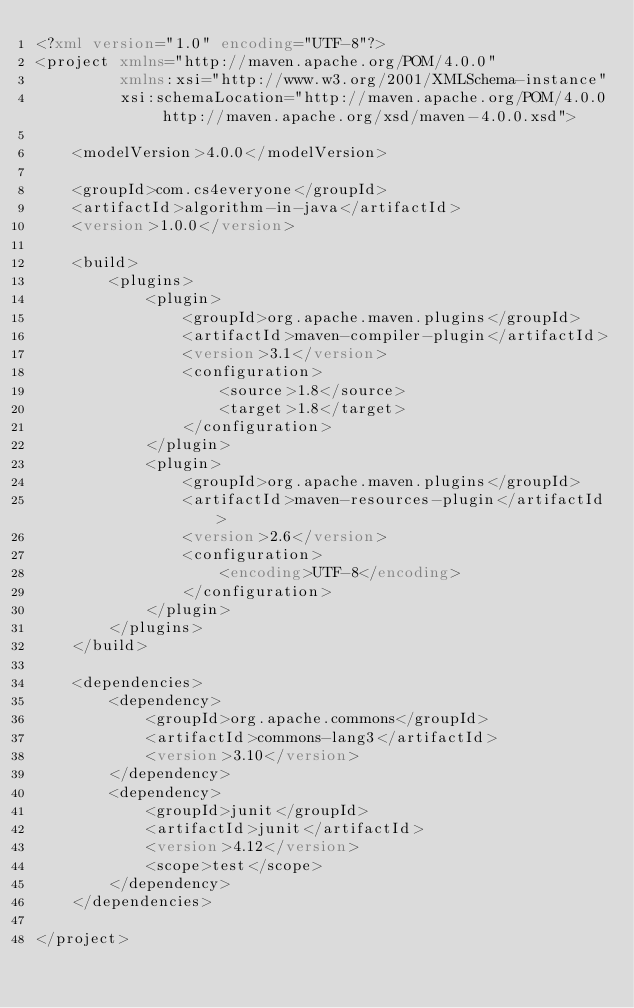Convert code to text. <code><loc_0><loc_0><loc_500><loc_500><_XML_><?xml version="1.0" encoding="UTF-8"?>
<project xmlns="http://maven.apache.org/POM/4.0.0"
         xmlns:xsi="http://www.w3.org/2001/XMLSchema-instance"
         xsi:schemaLocation="http://maven.apache.org/POM/4.0.0 http://maven.apache.org/xsd/maven-4.0.0.xsd">

    <modelVersion>4.0.0</modelVersion>

    <groupId>com.cs4everyone</groupId>
    <artifactId>algorithm-in-java</artifactId>
    <version>1.0.0</version>

    <build>
        <plugins>
            <plugin>
                <groupId>org.apache.maven.plugins</groupId>
                <artifactId>maven-compiler-plugin</artifactId>
                <version>3.1</version>
                <configuration>
                    <source>1.8</source>
                    <target>1.8</target>
                </configuration>
            </plugin>
            <plugin>
                <groupId>org.apache.maven.plugins</groupId>
                <artifactId>maven-resources-plugin</artifactId>
                <version>2.6</version>
                <configuration>
                    <encoding>UTF-8</encoding>
                </configuration>
            </plugin>
        </plugins>
    </build>

    <dependencies>
        <dependency>
            <groupId>org.apache.commons</groupId>
            <artifactId>commons-lang3</artifactId>
            <version>3.10</version>
        </dependency>
        <dependency>
            <groupId>junit</groupId>
            <artifactId>junit</artifactId>
            <version>4.12</version>
            <scope>test</scope>
        </dependency>
    </dependencies>

</project></code> 